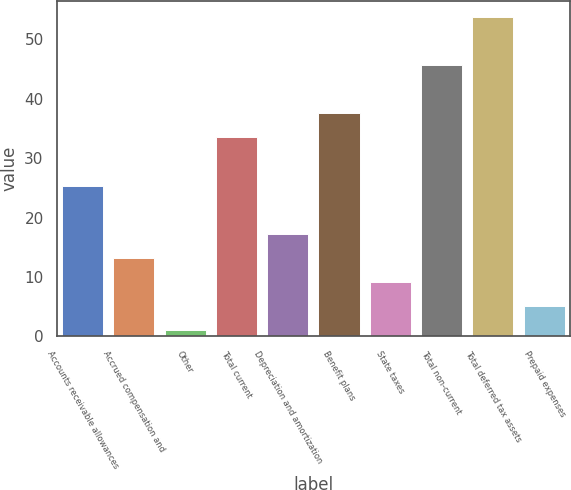Convert chart. <chart><loc_0><loc_0><loc_500><loc_500><bar_chart><fcel>Accounts receivable allowances<fcel>Accrued compensation and<fcel>Other<fcel>Total current<fcel>Depreciation and amortization<fcel>Benefit plans<fcel>State taxes<fcel>Total non-current<fcel>Total deferred tax assets<fcel>Prepaid expenses<nl><fcel>25.36<fcel>13.18<fcel>1<fcel>33.48<fcel>17.24<fcel>37.54<fcel>9.12<fcel>45.66<fcel>53.78<fcel>5.06<nl></chart> 